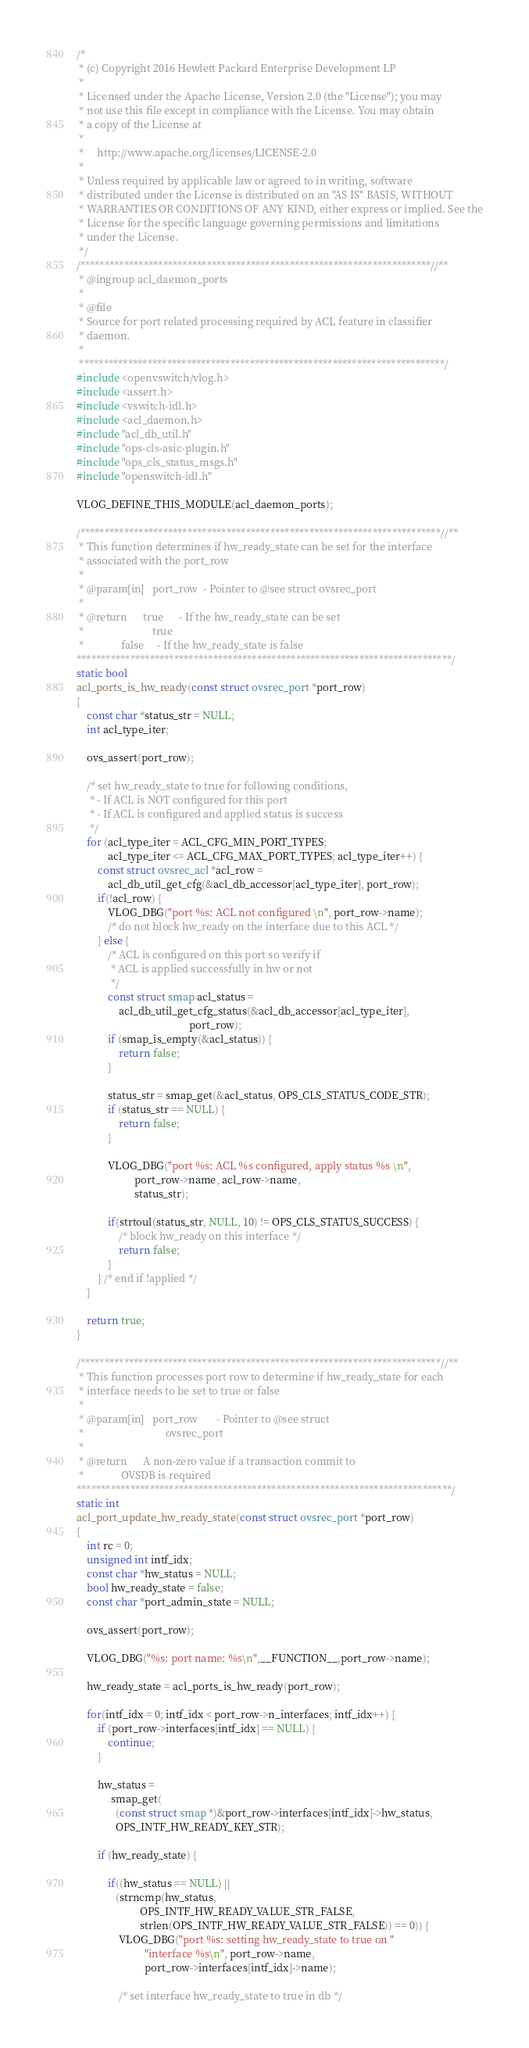<code> <loc_0><loc_0><loc_500><loc_500><_C_>/*
 * (c) Copyright 2016 Hewlett Packard Enterprise Development LP
 *
 * Licensed under the Apache License, Version 2.0 (the "License"); you may
 * not use this file except in compliance with the License. You may obtain
 * a copy of the License at
 *
 *     http://www.apache.org/licenses/LICENSE-2.0
 *
 * Unless required by applicable law or agreed to in writing, software
 * distributed under the License is distributed on an "AS IS" BASIS, WITHOUT
 * WARRANTIES OR CONDITIONS OF ANY KIND, either express or implied. See the
 * License for the specific language governing permissions and limitations
 * under the License.
 */
/************************************************************************//**
 * @ingroup acl_daemon_ports
 *
 * @file
 * Source for port related processing required by ACL feature in classifier
 * daemon.
 *
 ***************************************************************************/
#include <openvswitch/vlog.h>
#include <assert.h>
#include <vswitch-idl.h>
#include <acl_daemon.h>
#include "acl_db_util.h"
#include "ops-cls-asic-plugin.h"
#include "ops_cls_status_msgs.h"
#include "openswitch-idl.h"

VLOG_DEFINE_THIS_MODULE(acl_daemon_ports);

/**************************************************************************//**
 * This function determines if hw_ready_state can be set for the interface
 * associated with the port_row
 *
 * @param[in]   port_row  - Pointer to @see struct ovsrec_port
 *
 * @return      true      - If the hw_ready_state can be set
 *                          true
 *              false     - If the hw_ready_state is false
*****************************************************************************/
static bool
acl_ports_is_hw_ready(const struct ovsrec_port *port_row)
{
    const char *status_str = NULL;
    int acl_type_iter;

    ovs_assert(port_row);

    /* set hw_ready_state to true for following conditions,
     * - If ACL is NOT configured for this port
     * - If ACL is configured and applied status is success
     */
    for (acl_type_iter = ACL_CFG_MIN_PORT_TYPES;
            acl_type_iter <= ACL_CFG_MAX_PORT_TYPES; acl_type_iter++) {
        const struct ovsrec_acl *acl_row =
            acl_db_util_get_cfg(&acl_db_accessor[acl_type_iter], port_row);
        if(!acl_row) {
            VLOG_DBG("port %s: ACL not configured \n", port_row->name);
            /* do not block hw_ready on the interface due to this ACL */
        } else {
            /* ACL is configured on this port so verify if
             * ACL is applied successfully in hw or not
             */
            const struct smap acl_status =
                acl_db_util_get_cfg_status(&acl_db_accessor[acl_type_iter],
                                           port_row);
            if (smap_is_empty(&acl_status)) {
                return false;
            }

            status_str = smap_get(&acl_status, OPS_CLS_STATUS_CODE_STR);
            if (status_str == NULL) {
                return false;
            }

            VLOG_DBG("port %s: ACL %s configured, apply status %s \n",
                      port_row->name, acl_row->name,
                      status_str);

            if(strtoul(status_str, NULL, 10) != OPS_CLS_STATUS_SUCCESS) {
                /* block hw_ready on this interface */
                return false;
            }
        } /* end if !applied */
    }

    return true;
}

/**************************************************************************//**
 * This function processes port row to determine if hw_ready_state for each
 * interface needs to be set to true or false
 *
 * @param[in]   port_row       - Pointer to @see struct
 *                               ovsrec_port
 *
 * @return      A non-zero value if a transaction commit to
 *              OVSDB is required
*****************************************************************************/
static int
acl_port_update_hw_ready_state(const struct ovsrec_port *port_row)
{
    int rc = 0;
    unsigned int intf_idx;
    const char *hw_status = NULL;
    bool hw_ready_state = false;
    const char *port_admin_state = NULL;

    ovs_assert(port_row);

    VLOG_DBG("%s: port name: %s\n",__FUNCTION__,port_row->name);

    hw_ready_state = acl_ports_is_hw_ready(port_row);

    for(intf_idx = 0; intf_idx < port_row->n_interfaces; intf_idx++) {
        if (port_row->interfaces[intf_idx] == NULL) {
            continue;
        }

        hw_status =
             smap_get(
               (const struct smap *)&port_row->interfaces[intf_idx]->hw_status,
               OPS_INTF_HW_READY_KEY_STR);

        if (hw_ready_state) {

            if((hw_status == NULL) ||
               (strncmp(hw_status,
                        OPS_INTF_HW_READY_VALUE_STR_FALSE,
                        strlen(OPS_INTF_HW_READY_VALUE_STR_FALSE)) == 0)) {
                VLOG_DBG("port %s: setting hw_ready_state to true on "
                          "interface %s\n", port_row->name,
                          port_row->interfaces[intf_idx]->name);

                /* set interface hw_ready_state to true in db */</code> 